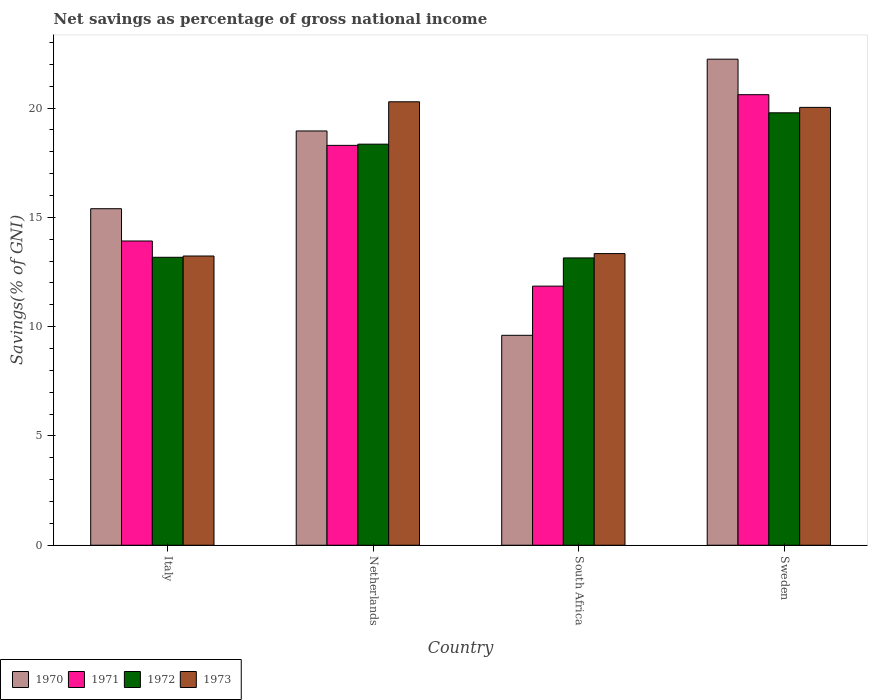How many different coloured bars are there?
Your response must be concise. 4. Are the number of bars per tick equal to the number of legend labels?
Provide a succinct answer. Yes. Are the number of bars on each tick of the X-axis equal?
Your answer should be very brief. Yes. How many bars are there on the 2nd tick from the right?
Your answer should be compact. 4. What is the label of the 3rd group of bars from the left?
Provide a short and direct response. South Africa. In how many cases, is the number of bars for a given country not equal to the number of legend labels?
Give a very brief answer. 0. What is the total savings in 1972 in Sweden?
Offer a very short reply. 19.78. Across all countries, what is the maximum total savings in 1973?
Provide a short and direct response. 20.29. Across all countries, what is the minimum total savings in 1971?
Provide a short and direct response. 11.85. In which country was the total savings in 1971 minimum?
Give a very brief answer. South Africa. What is the total total savings in 1970 in the graph?
Your answer should be compact. 66.19. What is the difference between the total savings in 1972 in Italy and that in Netherlands?
Provide a short and direct response. -5.18. What is the difference between the total savings in 1972 in South Africa and the total savings in 1971 in Netherlands?
Ensure brevity in your answer.  -5.15. What is the average total savings in 1970 per country?
Keep it short and to the point. 16.55. What is the difference between the total savings of/in 1972 and total savings of/in 1973 in South Africa?
Give a very brief answer. -0.2. What is the ratio of the total savings in 1970 in South Africa to that in Sweden?
Your answer should be very brief. 0.43. What is the difference between the highest and the second highest total savings in 1972?
Give a very brief answer. -1.43. What is the difference between the highest and the lowest total savings in 1972?
Ensure brevity in your answer.  6.64. In how many countries, is the total savings in 1970 greater than the average total savings in 1970 taken over all countries?
Ensure brevity in your answer.  2. Is the sum of the total savings in 1971 in Netherlands and Sweden greater than the maximum total savings in 1972 across all countries?
Provide a short and direct response. Yes. What does the 1st bar from the right in Sweden represents?
Make the answer very short. 1973. How many bars are there?
Provide a succinct answer. 16. Are all the bars in the graph horizontal?
Your answer should be very brief. No. What is the difference between two consecutive major ticks on the Y-axis?
Provide a short and direct response. 5. Are the values on the major ticks of Y-axis written in scientific E-notation?
Offer a very short reply. No. Where does the legend appear in the graph?
Provide a short and direct response. Bottom left. What is the title of the graph?
Provide a short and direct response. Net savings as percentage of gross national income. Does "1971" appear as one of the legend labels in the graph?
Your answer should be compact. Yes. What is the label or title of the X-axis?
Give a very brief answer. Country. What is the label or title of the Y-axis?
Offer a very short reply. Savings(% of GNI). What is the Savings(% of GNI) of 1970 in Italy?
Your answer should be very brief. 15.4. What is the Savings(% of GNI) of 1971 in Italy?
Offer a terse response. 13.92. What is the Savings(% of GNI) in 1972 in Italy?
Your answer should be very brief. 13.17. What is the Savings(% of GNI) of 1973 in Italy?
Give a very brief answer. 13.23. What is the Savings(% of GNI) of 1970 in Netherlands?
Keep it short and to the point. 18.95. What is the Savings(% of GNI) in 1971 in Netherlands?
Offer a terse response. 18.29. What is the Savings(% of GNI) of 1972 in Netherlands?
Offer a terse response. 18.35. What is the Savings(% of GNI) of 1973 in Netherlands?
Provide a succinct answer. 20.29. What is the Savings(% of GNI) in 1970 in South Africa?
Provide a short and direct response. 9.6. What is the Savings(% of GNI) of 1971 in South Africa?
Make the answer very short. 11.85. What is the Savings(% of GNI) in 1972 in South Africa?
Provide a short and direct response. 13.14. What is the Savings(% of GNI) of 1973 in South Africa?
Provide a succinct answer. 13.34. What is the Savings(% of GNI) of 1970 in Sweden?
Provide a succinct answer. 22.24. What is the Savings(% of GNI) in 1971 in Sweden?
Offer a very short reply. 20.61. What is the Savings(% of GNI) in 1972 in Sweden?
Your answer should be very brief. 19.78. What is the Savings(% of GNI) of 1973 in Sweden?
Provide a succinct answer. 20.03. Across all countries, what is the maximum Savings(% of GNI) of 1970?
Offer a very short reply. 22.24. Across all countries, what is the maximum Savings(% of GNI) of 1971?
Offer a very short reply. 20.61. Across all countries, what is the maximum Savings(% of GNI) of 1972?
Your response must be concise. 19.78. Across all countries, what is the maximum Savings(% of GNI) in 1973?
Keep it short and to the point. 20.29. Across all countries, what is the minimum Savings(% of GNI) in 1970?
Ensure brevity in your answer.  9.6. Across all countries, what is the minimum Savings(% of GNI) of 1971?
Your answer should be very brief. 11.85. Across all countries, what is the minimum Savings(% of GNI) of 1972?
Your response must be concise. 13.14. Across all countries, what is the minimum Savings(% of GNI) of 1973?
Offer a very short reply. 13.23. What is the total Savings(% of GNI) of 1970 in the graph?
Give a very brief answer. 66.19. What is the total Savings(% of GNI) of 1971 in the graph?
Offer a very short reply. 64.68. What is the total Savings(% of GNI) of 1972 in the graph?
Your answer should be very brief. 64.45. What is the total Savings(% of GNI) of 1973 in the graph?
Provide a short and direct response. 66.89. What is the difference between the Savings(% of GNI) in 1970 in Italy and that in Netherlands?
Provide a succinct answer. -3.56. What is the difference between the Savings(% of GNI) of 1971 in Italy and that in Netherlands?
Your answer should be very brief. -4.37. What is the difference between the Savings(% of GNI) in 1972 in Italy and that in Netherlands?
Provide a succinct answer. -5.18. What is the difference between the Savings(% of GNI) in 1973 in Italy and that in Netherlands?
Provide a short and direct response. -7.06. What is the difference between the Savings(% of GNI) of 1970 in Italy and that in South Africa?
Your answer should be very brief. 5.79. What is the difference between the Savings(% of GNI) of 1971 in Italy and that in South Africa?
Keep it short and to the point. 2.07. What is the difference between the Savings(% of GNI) in 1972 in Italy and that in South Africa?
Your answer should be compact. 0.03. What is the difference between the Savings(% of GNI) of 1973 in Italy and that in South Africa?
Give a very brief answer. -0.11. What is the difference between the Savings(% of GNI) in 1970 in Italy and that in Sweden?
Your answer should be very brief. -6.84. What is the difference between the Savings(% of GNI) of 1971 in Italy and that in Sweden?
Offer a very short reply. -6.69. What is the difference between the Savings(% of GNI) in 1972 in Italy and that in Sweden?
Make the answer very short. -6.61. What is the difference between the Savings(% of GNI) of 1973 in Italy and that in Sweden?
Offer a terse response. -6.8. What is the difference between the Savings(% of GNI) in 1970 in Netherlands and that in South Africa?
Keep it short and to the point. 9.35. What is the difference between the Savings(% of GNI) of 1971 in Netherlands and that in South Africa?
Keep it short and to the point. 6.44. What is the difference between the Savings(% of GNI) in 1972 in Netherlands and that in South Africa?
Provide a short and direct response. 5.21. What is the difference between the Savings(% of GNI) of 1973 in Netherlands and that in South Africa?
Offer a terse response. 6.95. What is the difference between the Savings(% of GNI) of 1970 in Netherlands and that in Sweden?
Offer a very short reply. -3.28. What is the difference between the Savings(% of GNI) of 1971 in Netherlands and that in Sweden?
Your response must be concise. -2.32. What is the difference between the Savings(% of GNI) of 1972 in Netherlands and that in Sweden?
Offer a very short reply. -1.43. What is the difference between the Savings(% of GNI) in 1973 in Netherlands and that in Sweden?
Offer a very short reply. 0.26. What is the difference between the Savings(% of GNI) in 1970 in South Africa and that in Sweden?
Offer a very short reply. -12.63. What is the difference between the Savings(% of GNI) of 1971 in South Africa and that in Sweden?
Your answer should be very brief. -8.76. What is the difference between the Savings(% of GNI) in 1972 in South Africa and that in Sweden?
Keep it short and to the point. -6.64. What is the difference between the Savings(% of GNI) of 1973 in South Africa and that in Sweden?
Offer a very short reply. -6.69. What is the difference between the Savings(% of GNI) in 1970 in Italy and the Savings(% of GNI) in 1971 in Netherlands?
Your answer should be compact. -2.9. What is the difference between the Savings(% of GNI) of 1970 in Italy and the Savings(% of GNI) of 1972 in Netherlands?
Keep it short and to the point. -2.95. What is the difference between the Savings(% of GNI) in 1970 in Italy and the Savings(% of GNI) in 1973 in Netherlands?
Keep it short and to the point. -4.89. What is the difference between the Savings(% of GNI) of 1971 in Italy and the Savings(% of GNI) of 1972 in Netherlands?
Keep it short and to the point. -4.43. What is the difference between the Savings(% of GNI) in 1971 in Italy and the Savings(% of GNI) in 1973 in Netherlands?
Keep it short and to the point. -6.37. What is the difference between the Savings(% of GNI) in 1972 in Italy and the Savings(% of GNI) in 1973 in Netherlands?
Provide a succinct answer. -7.11. What is the difference between the Savings(% of GNI) of 1970 in Italy and the Savings(% of GNI) of 1971 in South Africa?
Make the answer very short. 3.54. What is the difference between the Savings(% of GNI) of 1970 in Italy and the Savings(% of GNI) of 1972 in South Africa?
Offer a very short reply. 2.25. What is the difference between the Savings(% of GNI) of 1970 in Italy and the Savings(% of GNI) of 1973 in South Africa?
Your answer should be very brief. 2.05. What is the difference between the Savings(% of GNI) in 1971 in Italy and the Savings(% of GNI) in 1972 in South Africa?
Ensure brevity in your answer.  0.78. What is the difference between the Savings(% of GNI) of 1971 in Italy and the Savings(% of GNI) of 1973 in South Africa?
Keep it short and to the point. 0.58. What is the difference between the Savings(% of GNI) in 1972 in Italy and the Savings(% of GNI) in 1973 in South Africa?
Provide a short and direct response. -0.17. What is the difference between the Savings(% of GNI) in 1970 in Italy and the Savings(% of GNI) in 1971 in Sweden?
Give a very brief answer. -5.22. What is the difference between the Savings(% of GNI) in 1970 in Italy and the Savings(% of GNI) in 1972 in Sweden?
Give a very brief answer. -4.39. What is the difference between the Savings(% of GNI) in 1970 in Italy and the Savings(% of GNI) in 1973 in Sweden?
Offer a very short reply. -4.64. What is the difference between the Savings(% of GNI) in 1971 in Italy and the Savings(% of GNI) in 1972 in Sweden?
Make the answer very short. -5.86. What is the difference between the Savings(% of GNI) of 1971 in Italy and the Savings(% of GNI) of 1973 in Sweden?
Make the answer very short. -6.11. What is the difference between the Savings(% of GNI) in 1972 in Italy and the Savings(% of GNI) in 1973 in Sweden?
Give a very brief answer. -6.86. What is the difference between the Savings(% of GNI) in 1970 in Netherlands and the Savings(% of GNI) in 1971 in South Africa?
Provide a short and direct response. 7.1. What is the difference between the Savings(% of GNI) of 1970 in Netherlands and the Savings(% of GNI) of 1972 in South Africa?
Your response must be concise. 5.81. What is the difference between the Savings(% of GNI) of 1970 in Netherlands and the Savings(% of GNI) of 1973 in South Africa?
Your answer should be compact. 5.61. What is the difference between the Savings(% of GNI) of 1971 in Netherlands and the Savings(% of GNI) of 1972 in South Africa?
Provide a succinct answer. 5.15. What is the difference between the Savings(% of GNI) in 1971 in Netherlands and the Savings(% of GNI) in 1973 in South Africa?
Your answer should be very brief. 4.95. What is the difference between the Savings(% of GNI) in 1972 in Netherlands and the Savings(% of GNI) in 1973 in South Africa?
Keep it short and to the point. 5.01. What is the difference between the Savings(% of GNI) of 1970 in Netherlands and the Savings(% of GNI) of 1971 in Sweden?
Your answer should be very brief. -1.66. What is the difference between the Savings(% of GNI) of 1970 in Netherlands and the Savings(% of GNI) of 1972 in Sweden?
Provide a succinct answer. -0.83. What is the difference between the Savings(% of GNI) in 1970 in Netherlands and the Savings(% of GNI) in 1973 in Sweden?
Offer a terse response. -1.08. What is the difference between the Savings(% of GNI) in 1971 in Netherlands and the Savings(% of GNI) in 1972 in Sweden?
Your response must be concise. -1.49. What is the difference between the Savings(% of GNI) of 1971 in Netherlands and the Savings(% of GNI) of 1973 in Sweden?
Your response must be concise. -1.74. What is the difference between the Savings(% of GNI) of 1972 in Netherlands and the Savings(% of GNI) of 1973 in Sweden?
Your response must be concise. -1.68. What is the difference between the Savings(% of GNI) in 1970 in South Africa and the Savings(% of GNI) in 1971 in Sweden?
Your answer should be very brief. -11.01. What is the difference between the Savings(% of GNI) in 1970 in South Africa and the Savings(% of GNI) in 1972 in Sweden?
Provide a succinct answer. -10.18. What is the difference between the Savings(% of GNI) of 1970 in South Africa and the Savings(% of GNI) of 1973 in Sweden?
Offer a very short reply. -10.43. What is the difference between the Savings(% of GNI) in 1971 in South Africa and the Savings(% of GNI) in 1972 in Sweden?
Your answer should be compact. -7.93. What is the difference between the Savings(% of GNI) of 1971 in South Africa and the Savings(% of GNI) of 1973 in Sweden?
Offer a very short reply. -8.18. What is the difference between the Savings(% of GNI) of 1972 in South Africa and the Savings(% of GNI) of 1973 in Sweden?
Your answer should be very brief. -6.89. What is the average Savings(% of GNI) in 1970 per country?
Offer a terse response. 16.55. What is the average Savings(% of GNI) in 1971 per country?
Keep it short and to the point. 16.17. What is the average Savings(% of GNI) of 1972 per country?
Your answer should be very brief. 16.11. What is the average Savings(% of GNI) of 1973 per country?
Your response must be concise. 16.72. What is the difference between the Savings(% of GNI) of 1970 and Savings(% of GNI) of 1971 in Italy?
Ensure brevity in your answer.  1.48. What is the difference between the Savings(% of GNI) of 1970 and Savings(% of GNI) of 1972 in Italy?
Ensure brevity in your answer.  2.22. What is the difference between the Savings(% of GNI) in 1970 and Savings(% of GNI) in 1973 in Italy?
Provide a succinct answer. 2.16. What is the difference between the Savings(% of GNI) in 1971 and Savings(% of GNI) in 1972 in Italy?
Your answer should be very brief. 0.75. What is the difference between the Savings(% of GNI) in 1971 and Savings(% of GNI) in 1973 in Italy?
Offer a very short reply. 0.69. What is the difference between the Savings(% of GNI) of 1972 and Savings(% of GNI) of 1973 in Italy?
Give a very brief answer. -0.06. What is the difference between the Savings(% of GNI) in 1970 and Savings(% of GNI) in 1971 in Netherlands?
Offer a terse response. 0.66. What is the difference between the Savings(% of GNI) in 1970 and Savings(% of GNI) in 1972 in Netherlands?
Keep it short and to the point. 0.6. What is the difference between the Savings(% of GNI) in 1970 and Savings(% of GNI) in 1973 in Netherlands?
Offer a terse response. -1.33. What is the difference between the Savings(% of GNI) in 1971 and Savings(% of GNI) in 1972 in Netherlands?
Provide a succinct answer. -0.06. What is the difference between the Savings(% of GNI) of 1971 and Savings(% of GNI) of 1973 in Netherlands?
Your response must be concise. -1.99. What is the difference between the Savings(% of GNI) in 1972 and Savings(% of GNI) in 1973 in Netherlands?
Give a very brief answer. -1.94. What is the difference between the Savings(% of GNI) in 1970 and Savings(% of GNI) in 1971 in South Africa?
Keep it short and to the point. -2.25. What is the difference between the Savings(% of GNI) in 1970 and Savings(% of GNI) in 1972 in South Africa?
Your response must be concise. -3.54. What is the difference between the Savings(% of GNI) of 1970 and Savings(% of GNI) of 1973 in South Africa?
Offer a very short reply. -3.74. What is the difference between the Savings(% of GNI) in 1971 and Savings(% of GNI) in 1972 in South Africa?
Ensure brevity in your answer.  -1.29. What is the difference between the Savings(% of GNI) of 1971 and Savings(% of GNI) of 1973 in South Africa?
Provide a short and direct response. -1.49. What is the difference between the Savings(% of GNI) in 1972 and Savings(% of GNI) in 1973 in South Africa?
Ensure brevity in your answer.  -0.2. What is the difference between the Savings(% of GNI) in 1970 and Savings(% of GNI) in 1971 in Sweden?
Give a very brief answer. 1.62. What is the difference between the Savings(% of GNI) in 1970 and Savings(% of GNI) in 1972 in Sweden?
Offer a very short reply. 2.45. What is the difference between the Savings(% of GNI) of 1970 and Savings(% of GNI) of 1973 in Sweden?
Your response must be concise. 2.21. What is the difference between the Savings(% of GNI) of 1971 and Savings(% of GNI) of 1972 in Sweden?
Make the answer very short. 0.83. What is the difference between the Savings(% of GNI) in 1971 and Savings(% of GNI) in 1973 in Sweden?
Provide a succinct answer. 0.58. What is the difference between the Savings(% of GNI) of 1972 and Savings(% of GNI) of 1973 in Sweden?
Offer a terse response. -0.25. What is the ratio of the Savings(% of GNI) in 1970 in Italy to that in Netherlands?
Make the answer very short. 0.81. What is the ratio of the Savings(% of GNI) in 1971 in Italy to that in Netherlands?
Your answer should be very brief. 0.76. What is the ratio of the Savings(% of GNI) of 1972 in Italy to that in Netherlands?
Your answer should be very brief. 0.72. What is the ratio of the Savings(% of GNI) in 1973 in Italy to that in Netherlands?
Your response must be concise. 0.65. What is the ratio of the Savings(% of GNI) of 1970 in Italy to that in South Africa?
Offer a very short reply. 1.6. What is the ratio of the Savings(% of GNI) in 1971 in Italy to that in South Africa?
Give a very brief answer. 1.17. What is the ratio of the Savings(% of GNI) of 1973 in Italy to that in South Africa?
Provide a succinct answer. 0.99. What is the ratio of the Savings(% of GNI) of 1970 in Italy to that in Sweden?
Provide a short and direct response. 0.69. What is the ratio of the Savings(% of GNI) in 1971 in Italy to that in Sweden?
Offer a terse response. 0.68. What is the ratio of the Savings(% of GNI) in 1972 in Italy to that in Sweden?
Ensure brevity in your answer.  0.67. What is the ratio of the Savings(% of GNI) of 1973 in Italy to that in Sweden?
Your answer should be very brief. 0.66. What is the ratio of the Savings(% of GNI) in 1970 in Netherlands to that in South Africa?
Give a very brief answer. 1.97. What is the ratio of the Savings(% of GNI) of 1971 in Netherlands to that in South Africa?
Provide a short and direct response. 1.54. What is the ratio of the Savings(% of GNI) in 1972 in Netherlands to that in South Africa?
Your response must be concise. 1.4. What is the ratio of the Savings(% of GNI) in 1973 in Netherlands to that in South Africa?
Make the answer very short. 1.52. What is the ratio of the Savings(% of GNI) of 1970 in Netherlands to that in Sweden?
Ensure brevity in your answer.  0.85. What is the ratio of the Savings(% of GNI) in 1971 in Netherlands to that in Sweden?
Provide a short and direct response. 0.89. What is the ratio of the Savings(% of GNI) of 1972 in Netherlands to that in Sweden?
Keep it short and to the point. 0.93. What is the ratio of the Savings(% of GNI) of 1973 in Netherlands to that in Sweden?
Ensure brevity in your answer.  1.01. What is the ratio of the Savings(% of GNI) in 1970 in South Africa to that in Sweden?
Keep it short and to the point. 0.43. What is the ratio of the Savings(% of GNI) in 1971 in South Africa to that in Sweden?
Ensure brevity in your answer.  0.58. What is the ratio of the Savings(% of GNI) of 1972 in South Africa to that in Sweden?
Give a very brief answer. 0.66. What is the ratio of the Savings(% of GNI) of 1973 in South Africa to that in Sweden?
Your answer should be compact. 0.67. What is the difference between the highest and the second highest Savings(% of GNI) in 1970?
Your answer should be compact. 3.28. What is the difference between the highest and the second highest Savings(% of GNI) of 1971?
Keep it short and to the point. 2.32. What is the difference between the highest and the second highest Savings(% of GNI) in 1972?
Make the answer very short. 1.43. What is the difference between the highest and the second highest Savings(% of GNI) of 1973?
Your answer should be very brief. 0.26. What is the difference between the highest and the lowest Savings(% of GNI) in 1970?
Your answer should be compact. 12.63. What is the difference between the highest and the lowest Savings(% of GNI) in 1971?
Keep it short and to the point. 8.76. What is the difference between the highest and the lowest Savings(% of GNI) in 1972?
Your answer should be very brief. 6.64. What is the difference between the highest and the lowest Savings(% of GNI) in 1973?
Your answer should be compact. 7.06. 